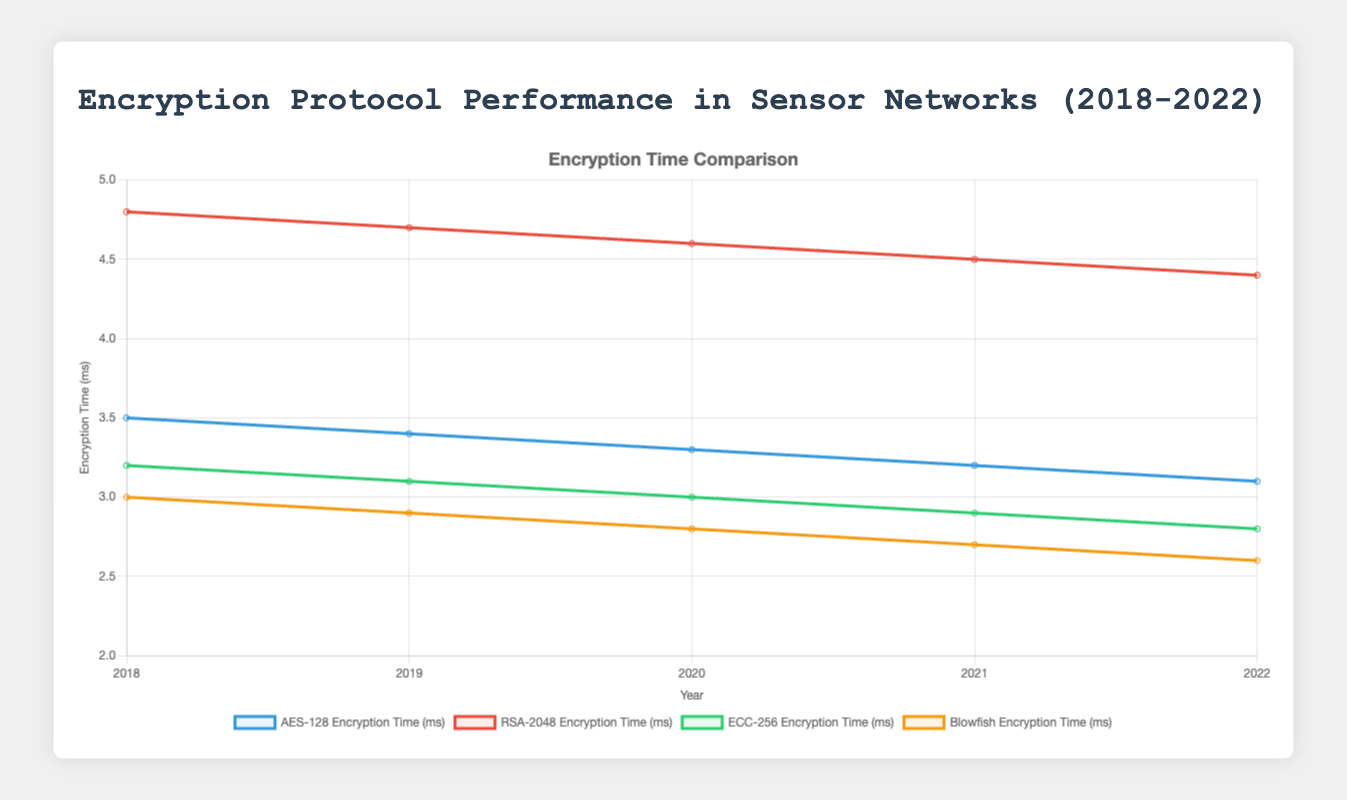What's the trend in encryption time for AES-128 from 2018 to 2022? By observing the plotted line for AES-128 in blue, we see a downward slope from 3.5 ms in 2018 to 3.1 ms in 2022.
Answer: Decreasing Which protocol had the fastest encryption time in 2022? Comparing the lowest points among all protocols for the year 2022, we find that Blowfish, indicated by the yellow line, has the lowest encryption time of 2.6 ms.
Answer: Blowfish Which year had the highest encryption time for RSA-2048? Looking at the red line representing RSA-2048, the peak occurs in 2018 with a maximum value of 4.8 ms.
Answer: 2018 How much did the encryption time for ECC-256 decrease from 2018 to 2022? The green line for ECC-256 shows a decrease from 3.2 ms in 2018 to 2.8 ms in 2022. The decrease is calculated as 3.2 - 2.8 = 0.4 ms.
Answer: 0.4 ms In which year did Blowfish have the largest difference between its encryption and decryption times? The differences each year are: 2018 (0), 2019 (0.1), 2020 (0.1), 2021 (0.1), 2022 (0.1). The largest difference is in any of the years from 2019 to 2022, with 0.1 ms.
Answer: 2019 to 2022 How does the encryption time trend for RSA-2048 compare to AES-128? RSA-2048 shows a consistent decrease every year from 4.8 ms in 2018 to 4.4 ms in 2022. Similarly, AES-128 decreases from 3.5 ms in 2018 to 3.1 ms in 2022. Both show a decreasing trend but RSA-2048 consistently remains higher.
Answer: Both decreasing, RSA-2048 higher Which protocol had the most significant improvement in encryption time from 2018 to 2022? Comparing the differences between 2018 and 2022: AES-128 (3.5 - 3.1 = 0.4 ms), RSA-2048 (4.8 - 4.4 = 0.4 ms), ECC-256 (3.2 - 2.8 = 0.4 ms), Blowfish (3.0 - 2.6 = 0.4 ms). All protocols improved by 0.4 ms.
Answer: All improved equally by 0.4 ms 